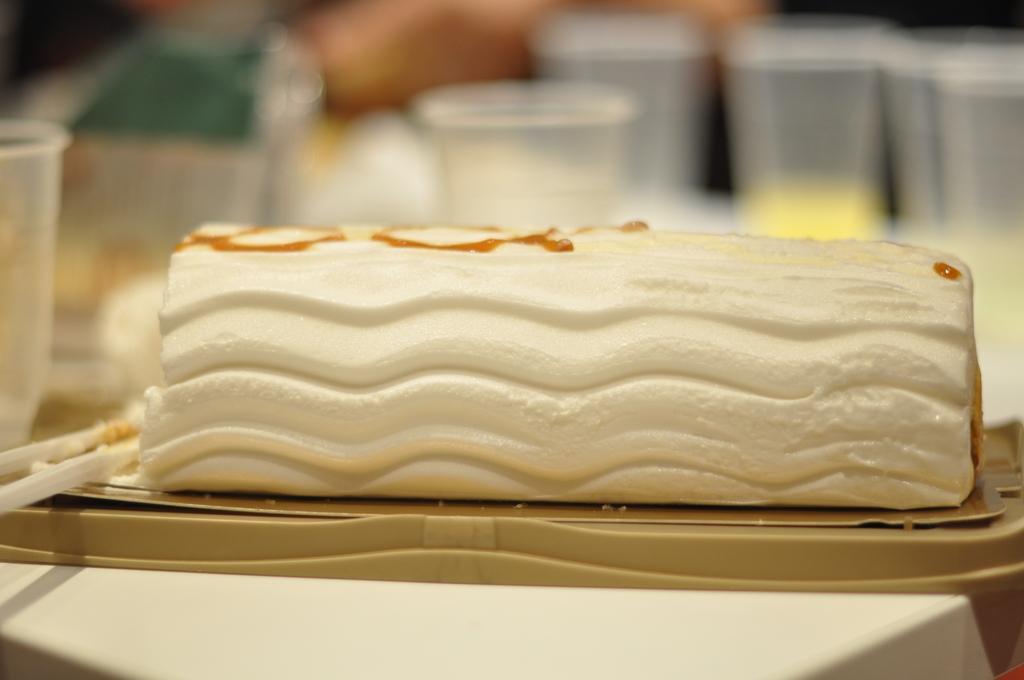Can you describe this image briefly? In this image there is a food item on plastic box in the foreground. There is a blur image, glasses in the background. 